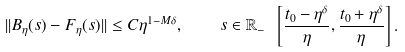<formula> <loc_0><loc_0><loc_500><loc_500>| | B _ { \eta } ( s ) - F _ { \eta } ( s ) | | \leq C \eta ^ { 1 - M \delta } , \quad s \in \mathbb { R } _ { - } \ \left [ \frac { t _ { 0 } - \eta ^ { \delta } } { \eta } , \frac { t _ { 0 } + \eta ^ { \delta } } { \eta } \right ] .</formula> 